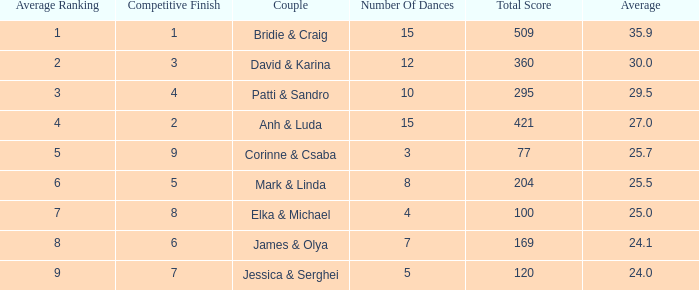Which pair has 295 as a combined score? Patti & Sandro. 